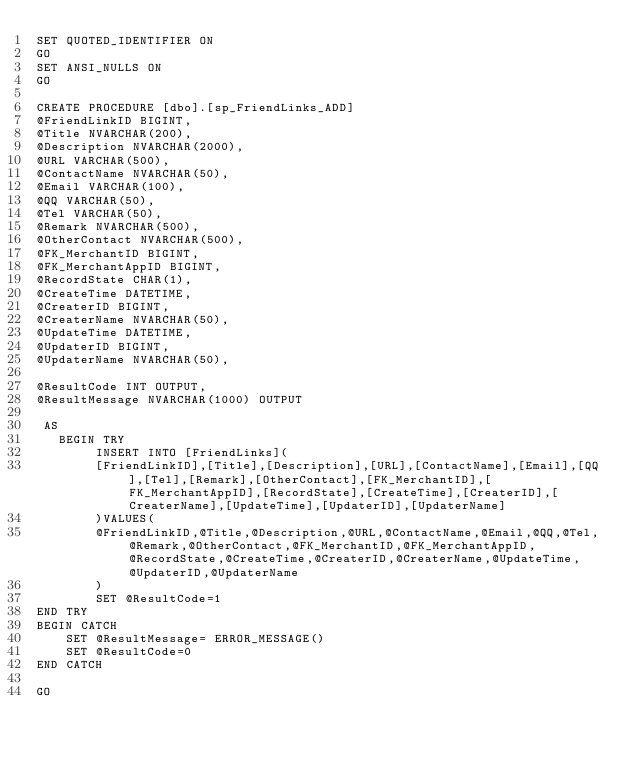Convert code to text. <code><loc_0><loc_0><loc_500><loc_500><_SQL_>SET QUOTED_IDENTIFIER ON
GO
SET ANSI_NULLS ON
GO

CREATE PROCEDURE [dbo].[sp_FriendLinks_ADD]
@FriendLinkID BIGINT,
@Title NVARCHAR(200),
@Description NVARCHAR(2000),
@URL VARCHAR(500),
@ContactName NVARCHAR(50),
@Email VARCHAR(100),
@QQ VARCHAR(50),
@Tel VARCHAR(50),
@Remark NVARCHAR(500),
@OtherContact NVARCHAR(500),
@FK_MerchantID BIGINT,
@FK_MerchantAppID BIGINT,
@RecordState CHAR(1),
@CreateTime DATETIME,
@CreaterID BIGINT,
@CreaterName NVARCHAR(50),
@UpdateTime DATETIME,
@UpdaterID BIGINT,
@UpdaterName NVARCHAR(50),

@ResultCode INT OUTPUT,
@ResultMessage NVARCHAR(1000) OUTPUT

 AS 
   BEGIN TRY
		INSERT INTO [FriendLinks](
		[FriendLinkID],[Title],[Description],[URL],[ContactName],[Email],[QQ],[Tel],[Remark],[OtherContact],[FK_MerchantID],[FK_MerchantAppID],[RecordState],[CreateTime],[CreaterID],[CreaterName],[UpdateTime],[UpdaterID],[UpdaterName]
		)VALUES(
		@FriendLinkID,@Title,@Description,@URL,@ContactName,@Email,@QQ,@Tel,@Remark,@OtherContact,@FK_MerchantID,@FK_MerchantAppID,@RecordState,@CreateTime,@CreaterID,@CreaterName,@UpdateTime,@UpdaterID,@UpdaterName
		)
		SET @ResultCode=1
END TRY
BEGIN CATCH
	SET @ResultMessage= ERROR_MESSAGE() 
	SET @ResultCode=0
END CATCH

GO
</code> 